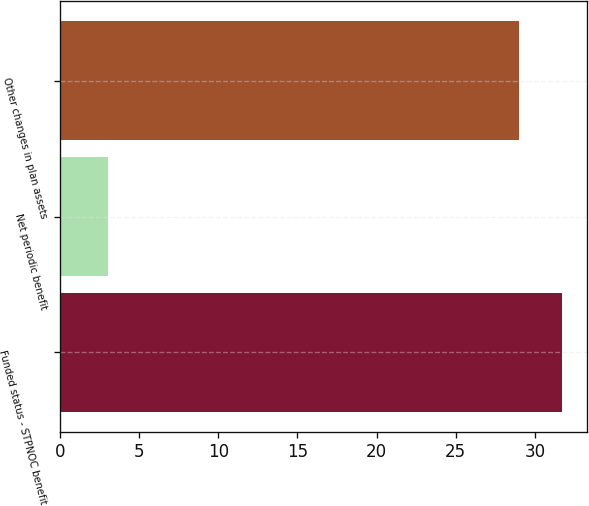Convert chart. <chart><loc_0><loc_0><loc_500><loc_500><bar_chart><fcel>Funded status - STPNOC benefit<fcel>Net periodic benefit<fcel>Other changes in plan assets<nl><fcel>31.7<fcel>3<fcel>29<nl></chart> 